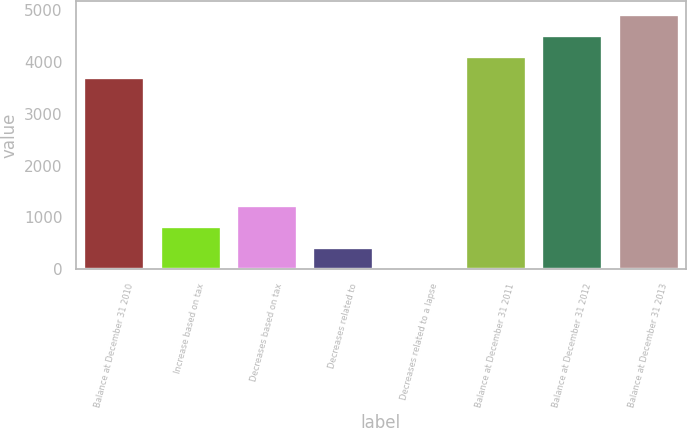Convert chart to OTSL. <chart><loc_0><loc_0><loc_500><loc_500><bar_chart><fcel>Balance at December 31 2010<fcel>Increase based on tax<fcel>Decreases based on tax<fcel>Decreases related to<fcel>Decreases related to a lapse<fcel>Balance at December 31 2011<fcel>Balance at December 31 2012<fcel>Balance at December 31 2013<nl><fcel>3711<fcel>829.6<fcel>1237.9<fcel>421.3<fcel>13<fcel>4119.3<fcel>4527.6<fcel>4935.9<nl></chart> 